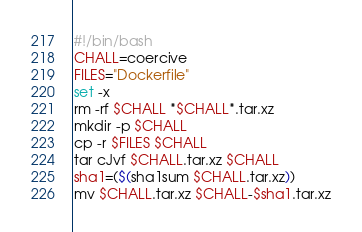Convert code to text. <code><loc_0><loc_0><loc_500><loc_500><_Bash_>#!/bin/bash
CHALL=coercive
FILES="Dockerfile"
set -x
rm -rf $CHALL *$CHALL*.tar.xz
mkdir -p $CHALL
cp -r $FILES $CHALL
tar cJvf $CHALL.tar.xz $CHALL
sha1=($(sha1sum $CHALL.tar.xz))
mv $CHALL.tar.xz $CHALL-$sha1.tar.xz
</code> 